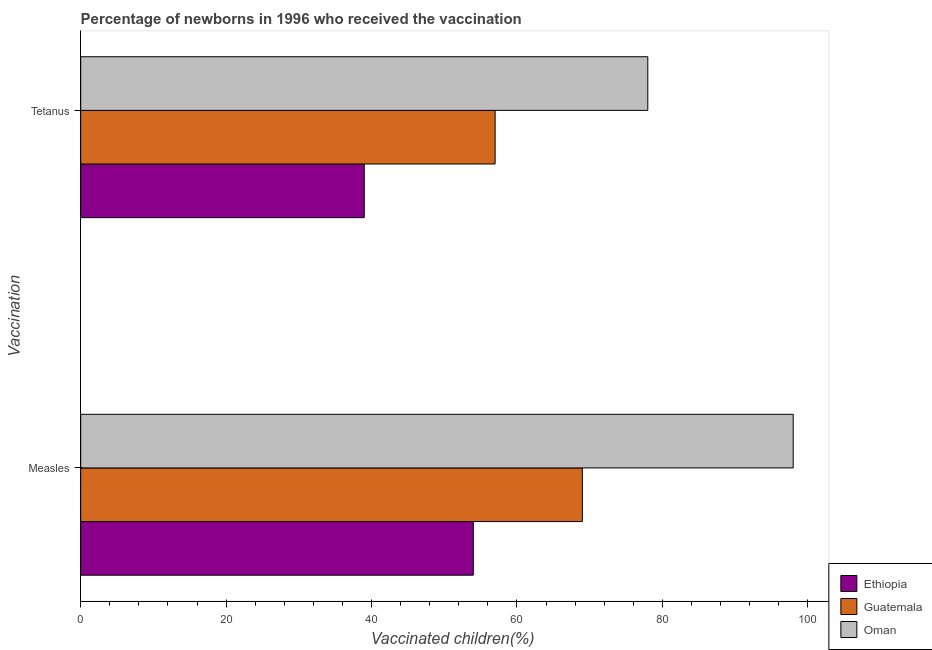How many different coloured bars are there?
Make the answer very short. 3. How many groups of bars are there?
Ensure brevity in your answer.  2. Are the number of bars per tick equal to the number of legend labels?
Keep it short and to the point. Yes. How many bars are there on the 2nd tick from the top?
Provide a short and direct response. 3. How many bars are there on the 2nd tick from the bottom?
Provide a short and direct response. 3. What is the label of the 2nd group of bars from the top?
Your response must be concise. Measles. What is the percentage of newborns who received vaccination for tetanus in Guatemala?
Your answer should be compact. 57. Across all countries, what is the maximum percentage of newborns who received vaccination for tetanus?
Ensure brevity in your answer.  78. Across all countries, what is the minimum percentage of newborns who received vaccination for measles?
Your answer should be compact. 54. In which country was the percentage of newborns who received vaccination for measles maximum?
Keep it short and to the point. Oman. In which country was the percentage of newborns who received vaccination for tetanus minimum?
Provide a short and direct response. Ethiopia. What is the total percentage of newborns who received vaccination for tetanus in the graph?
Give a very brief answer. 174. What is the difference between the percentage of newborns who received vaccination for measles in Guatemala and that in Oman?
Your answer should be compact. -29. What is the difference between the percentage of newborns who received vaccination for measles in Ethiopia and the percentage of newborns who received vaccination for tetanus in Oman?
Provide a succinct answer. -24. What is the average percentage of newborns who received vaccination for tetanus per country?
Give a very brief answer. 58. What is the difference between the percentage of newborns who received vaccination for tetanus and percentage of newborns who received vaccination for measles in Oman?
Offer a very short reply. -20. In how many countries, is the percentage of newborns who received vaccination for measles greater than 68 %?
Offer a terse response. 2. What is the ratio of the percentage of newborns who received vaccination for measles in Guatemala to that in Ethiopia?
Provide a short and direct response. 1.28. Is the percentage of newborns who received vaccination for tetanus in Guatemala less than that in Ethiopia?
Your response must be concise. No. What does the 3rd bar from the top in Tetanus represents?
Give a very brief answer. Ethiopia. What does the 2nd bar from the bottom in Measles represents?
Ensure brevity in your answer.  Guatemala. Are all the bars in the graph horizontal?
Your answer should be compact. Yes. What is the difference between two consecutive major ticks on the X-axis?
Your answer should be very brief. 20. Are the values on the major ticks of X-axis written in scientific E-notation?
Make the answer very short. No. Does the graph contain grids?
Your answer should be very brief. No. Where does the legend appear in the graph?
Provide a short and direct response. Bottom right. What is the title of the graph?
Your response must be concise. Percentage of newborns in 1996 who received the vaccination. Does "High income: OECD" appear as one of the legend labels in the graph?
Your response must be concise. No. What is the label or title of the X-axis?
Offer a terse response. Vaccinated children(%)
. What is the label or title of the Y-axis?
Offer a very short reply. Vaccination. What is the Vaccinated children(%)
 of Ethiopia in Measles?
Make the answer very short. 54. What is the Vaccinated children(%)
 of Oman in Measles?
Make the answer very short. 98. What is the Vaccinated children(%)
 in Oman in Tetanus?
Provide a short and direct response. 78. Across all Vaccination, what is the maximum Vaccinated children(%)
 in Guatemala?
Your answer should be very brief. 69. Across all Vaccination, what is the maximum Vaccinated children(%)
 in Oman?
Offer a very short reply. 98. Across all Vaccination, what is the minimum Vaccinated children(%)
 in Ethiopia?
Offer a terse response. 39. Across all Vaccination, what is the minimum Vaccinated children(%)
 in Oman?
Provide a succinct answer. 78. What is the total Vaccinated children(%)
 of Ethiopia in the graph?
Give a very brief answer. 93. What is the total Vaccinated children(%)
 of Guatemala in the graph?
Your answer should be compact. 126. What is the total Vaccinated children(%)
 in Oman in the graph?
Offer a terse response. 176. What is the difference between the Vaccinated children(%)
 of Ethiopia in Measles and that in Tetanus?
Your response must be concise. 15. What is the difference between the Vaccinated children(%)
 in Ethiopia in Measles and the Vaccinated children(%)
 in Guatemala in Tetanus?
Provide a succinct answer. -3. What is the average Vaccinated children(%)
 in Ethiopia per Vaccination?
Provide a short and direct response. 46.5. What is the average Vaccinated children(%)
 of Oman per Vaccination?
Provide a succinct answer. 88. What is the difference between the Vaccinated children(%)
 in Ethiopia and Vaccinated children(%)
 in Oman in Measles?
Provide a short and direct response. -44. What is the difference between the Vaccinated children(%)
 of Guatemala and Vaccinated children(%)
 of Oman in Measles?
Provide a succinct answer. -29. What is the difference between the Vaccinated children(%)
 of Ethiopia and Vaccinated children(%)
 of Oman in Tetanus?
Offer a very short reply. -39. What is the ratio of the Vaccinated children(%)
 in Ethiopia in Measles to that in Tetanus?
Make the answer very short. 1.38. What is the ratio of the Vaccinated children(%)
 in Guatemala in Measles to that in Tetanus?
Offer a terse response. 1.21. What is the ratio of the Vaccinated children(%)
 in Oman in Measles to that in Tetanus?
Provide a succinct answer. 1.26. What is the difference between the highest and the second highest Vaccinated children(%)
 of Guatemala?
Your answer should be very brief. 12. What is the difference between the highest and the lowest Vaccinated children(%)
 in Ethiopia?
Offer a terse response. 15. What is the difference between the highest and the lowest Vaccinated children(%)
 in Guatemala?
Keep it short and to the point. 12. What is the difference between the highest and the lowest Vaccinated children(%)
 in Oman?
Provide a short and direct response. 20. 